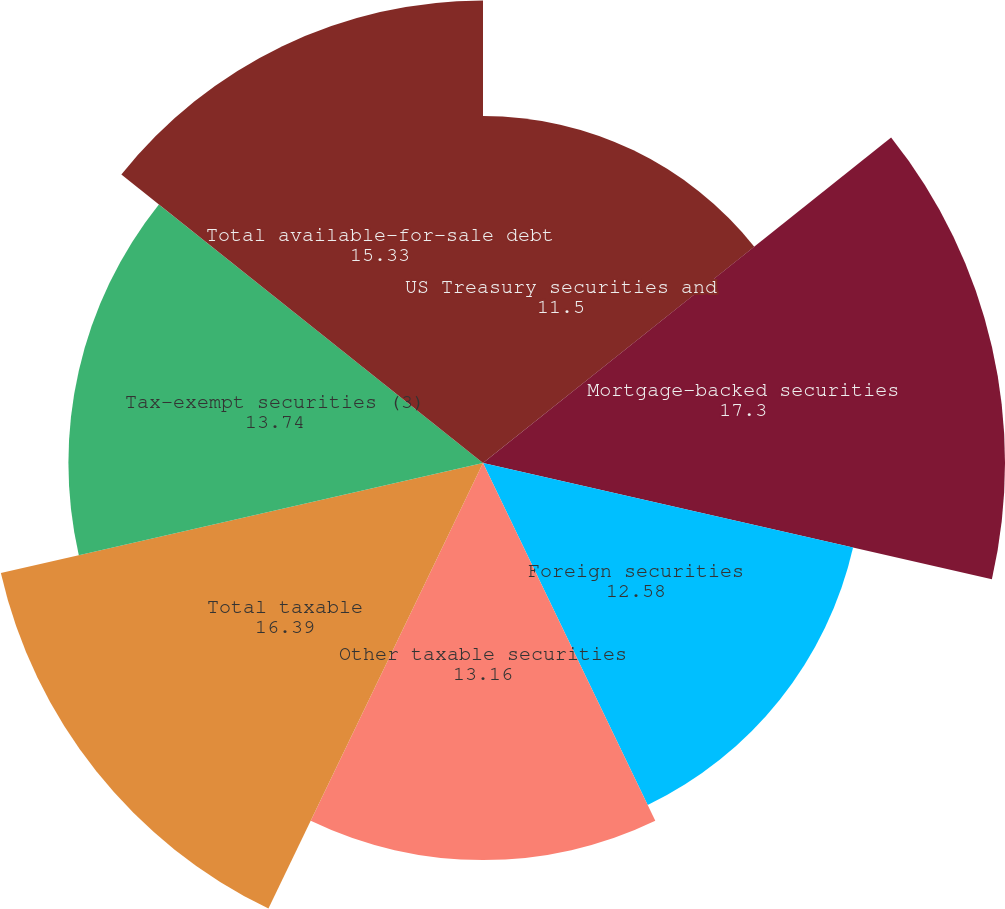<chart> <loc_0><loc_0><loc_500><loc_500><pie_chart><fcel>US Treasury securities and<fcel>Mortgage-backed securities<fcel>Foreign securities<fcel>Other taxable securities<fcel>Total taxable<fcel>Tax-exempt securities (3)<fcel>Total available-for-sale debt<nl><fcel>11.5%<fcel>17.3%<fcel>12.58%<fcel>13.16%<fcel>16.39%<fcel>13.74%<fcel>15.33%<nl></chart> 